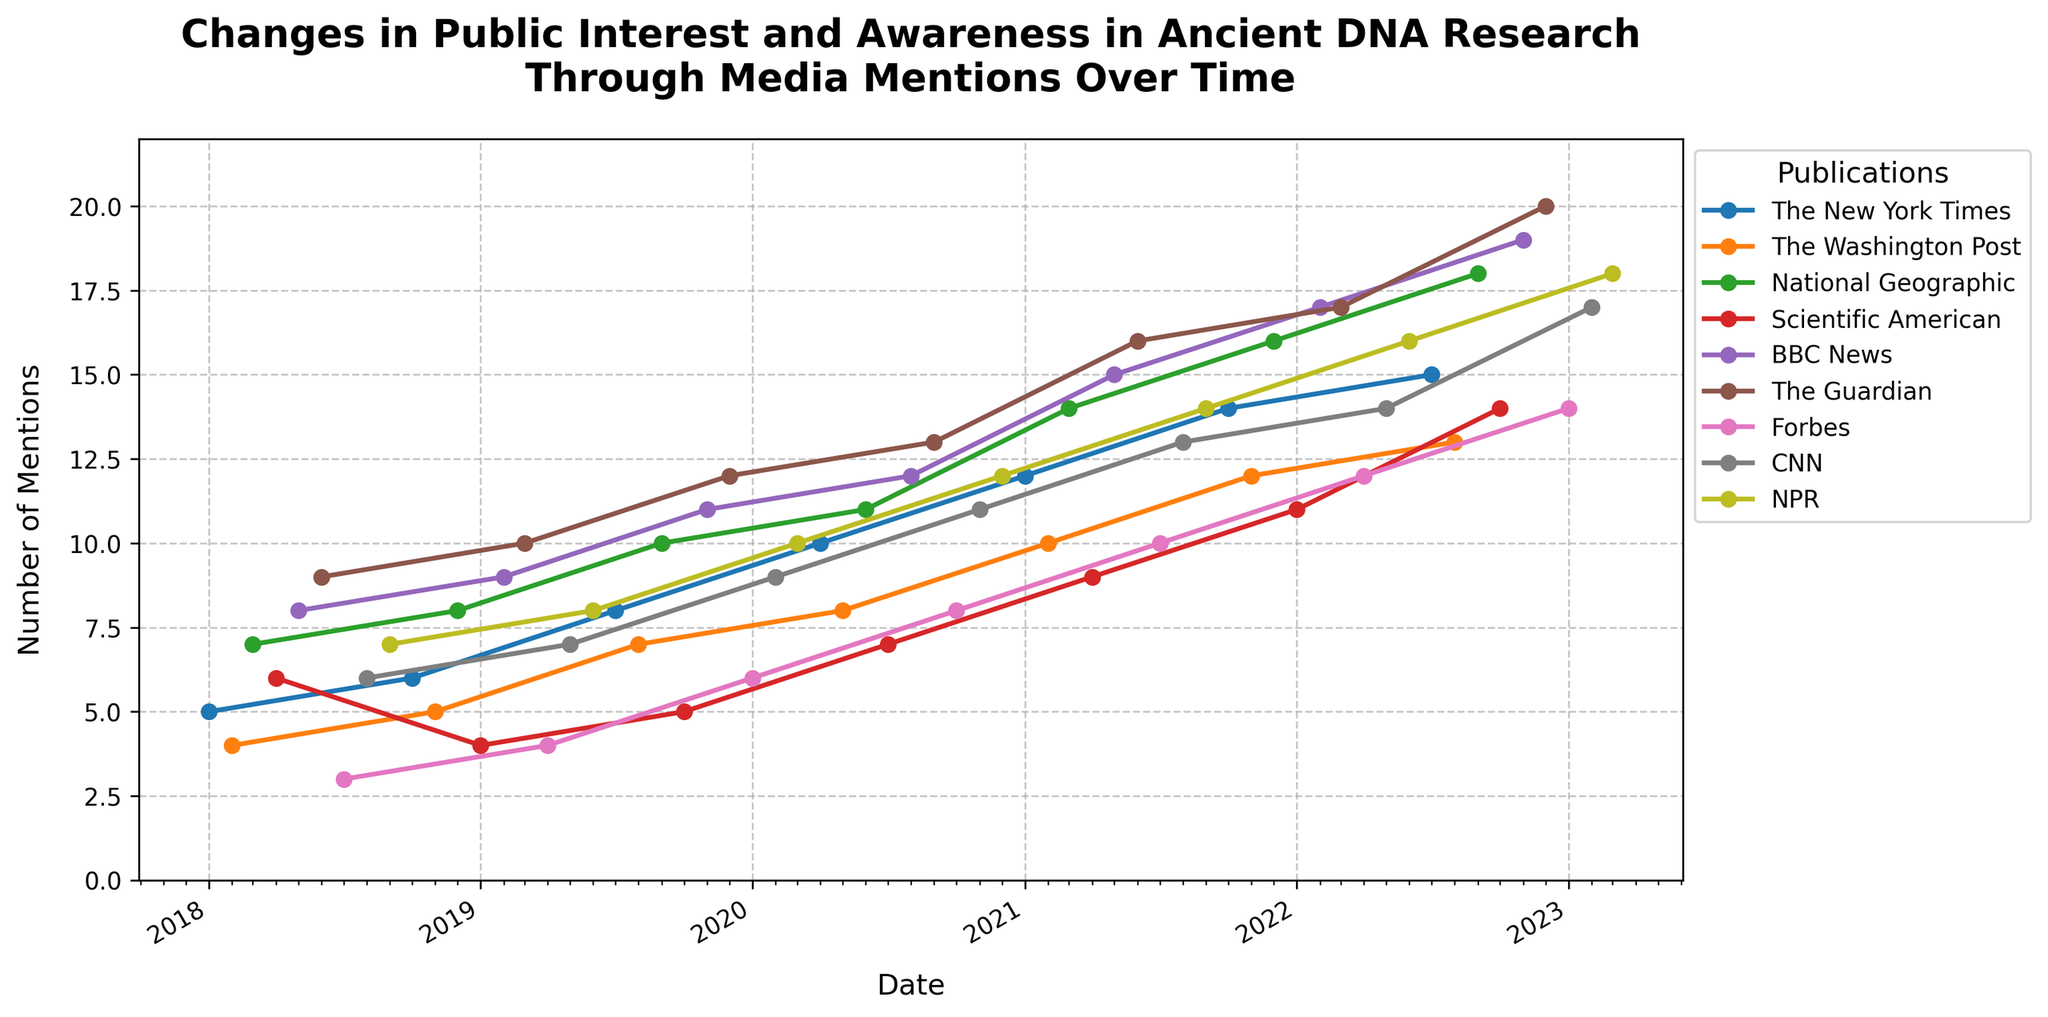What is the title of the plot? The title is usually located at the top of the plot. For this figure, the title is clearly displayed.
Answer: Changes in Public Interest and Awareness in Ancient DNA Research Through Media Mentions Over Time What is the range of the y-axis? The y-axis range can be determined by looking at the lowest and highest values marked along the y-axis. In this figure, the lowest value starts at 0 and the highest value goes up to the maximum number of mentions plus 2.
Answer: 0 to 22 How many mentions did BBC News have in December 2022? Locate December 2022 on the x-axis and find the corresponding data point for BBC News. The y-coordinate of this point is the number of mentions.
Answer: 19 Which publication had the highest number of mentions in March 2021? Identify all the data points in March 2021 and check which publication has the highest vertical position on the plot.
Answer: National Geographic When did The Guardian reach the peak number of mentions and what was the value? To determine the peak, trace The Guardian's line to its highest y-coordinate and note the corresponding date on the x-axis.
Answer: December 2022, 20 Calculate the average number of mentions for The New York Times in 2020. For each month in 2020, locate the mentions for The New York Times, add them up, and divide by the number of points.
Answer: (10 + 8 + 15) / 3 = 11 Compare the number of mentions for CNN between January 2021 and February 2023. Which month had more mentions and by how much? Find the mentions for CNN in January 2021 and February 2023, then subtract the smaller number from the larger.
Answer: February 2023 by 5 mentions How did the number of mentions for National Geographic change from September 2022 to September 2023? Locate these two months and note the mentions for National Geographic in each. Calculate the difference between the two values.
Answer: Increased by 8 Which month and year saw Forbes having exactly 10 mentions? Look for the distinct data point where Forbes' line intersects the exact 10 mentions mark on the y-axis and note the corresponding date on the x-axis.
Answer: July 2021 What trend can be observed for Scientific American's mentions from 2018 to 2023? Follow the line representing Scientific American from 2018 to 2023 and describe the overall direction whether it is increasing, decreasing, or stable.
Answer: Increasing 